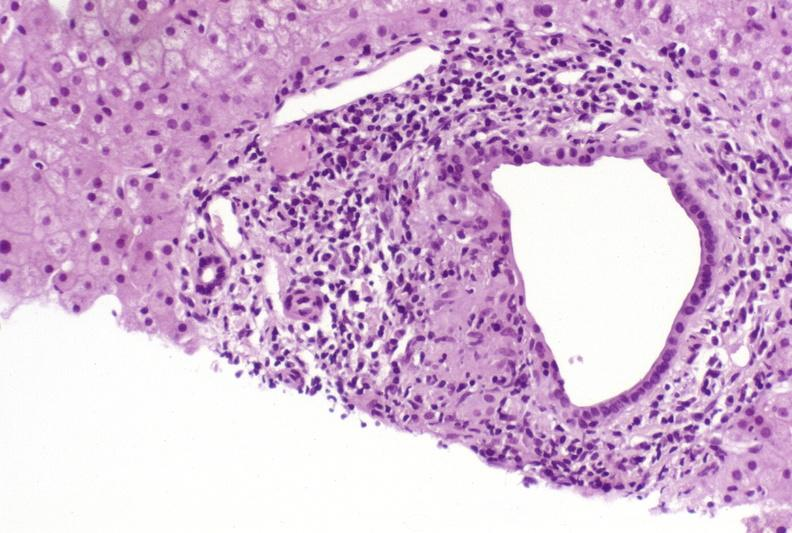does this good yellow color slide show primary biliary cirrhosis?
Answer the question using a single word or phrase. No 